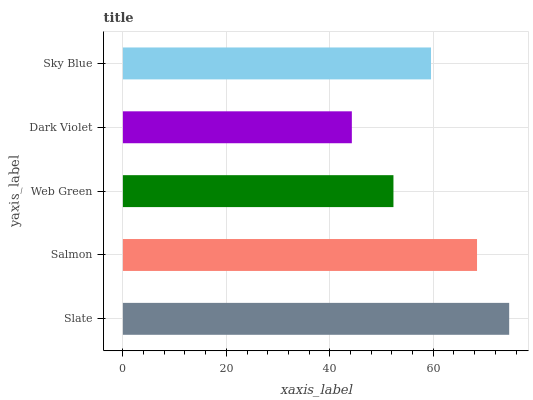Is Dark Violet the minimum?
Answer yes or no. Yes. Is Slate the maximum?
Answer yes or no. Yes. Is Salmon the minimum?
Answer yes or no. No. Is Salmon the maximum?
Answer yes or no. No. Is Slate greater than Salmon?
Answer yes or no. Yes. Is Salmon less than Slate?
Answer yes or no. Yes. Is Salmon greater than Slate?
Answer yes or no. No. Is Slate less than Salmon?
Answer yes or no. No. Is Sky Blue the high median?
Answer yes or no. Yes. Is Sky Blue the low median?
Answer yes or no. Yes. Is Salmon the high median?
Answer yes or no. No. Is Salmon the low median?
Answer yes or no. No. 